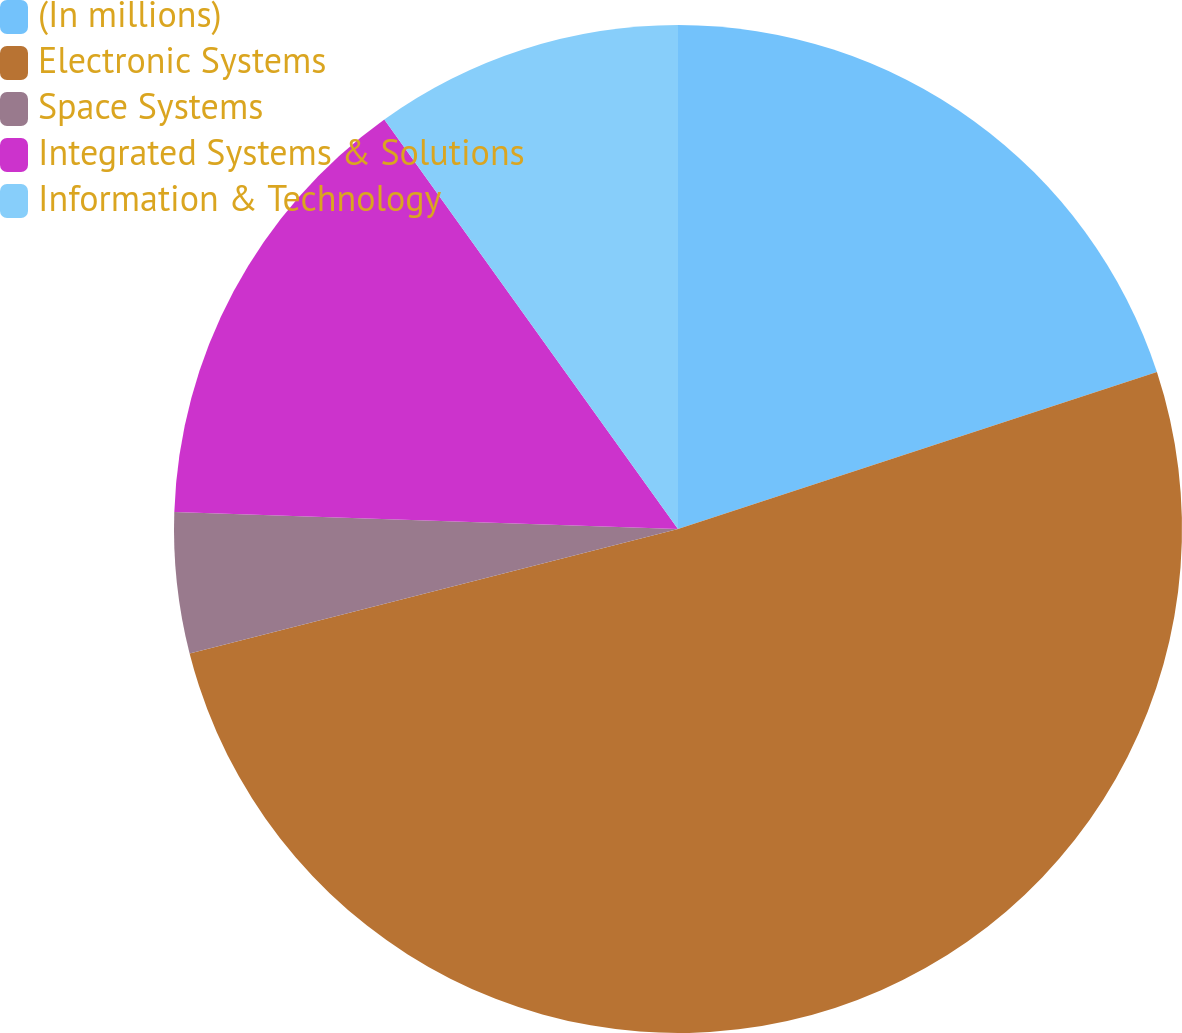Convert chart to OTSL. <chart><loc_0><loc_0><loc_500><loc_500><pie_chart><fcel>(In millions)<fcel>Electronic Systems<fcel>Space Systems<fcel>Integrated Systems & Solutions<fcel>Information & Technology<nl><fcel>19.96%<fcel>51.07%<fcel>4.51%<fcel>14.56%<fcel>9.9%<nl></chart> 